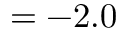<formula> <loc_0><loc_0><loc_500><loc_500>= - 2 . 0</formula> 